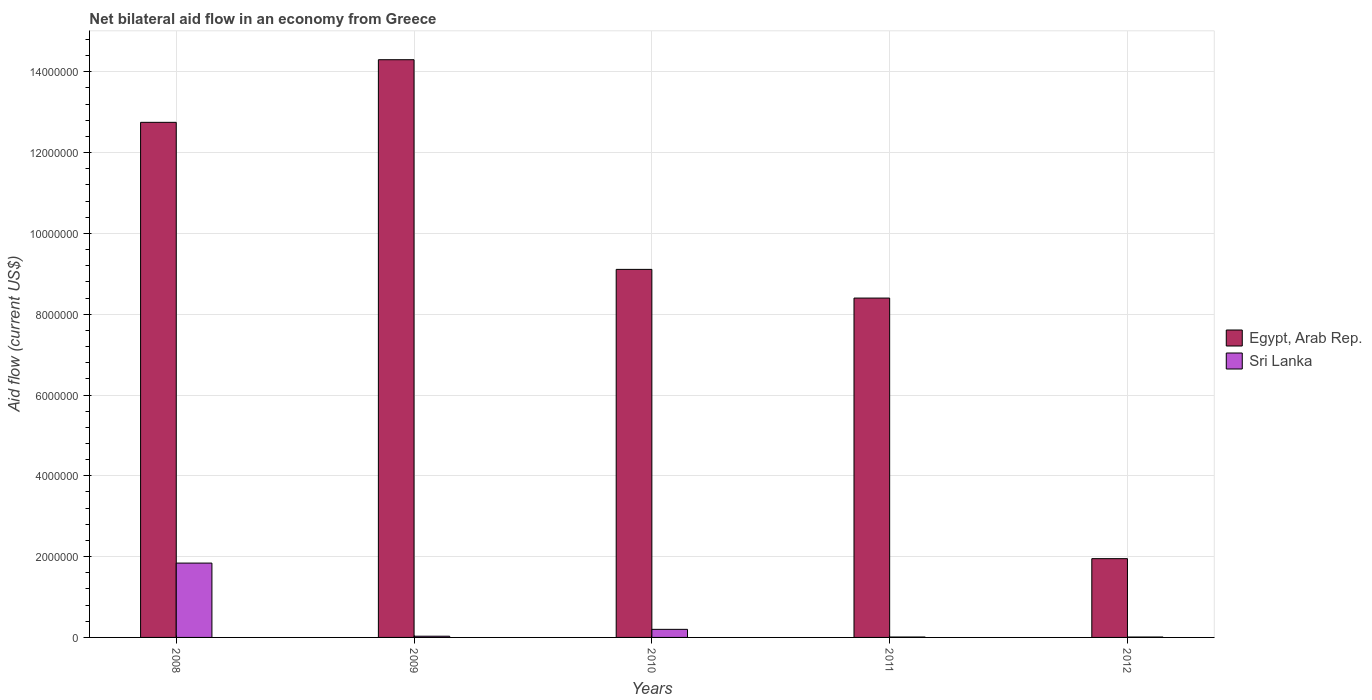How many different coloured bars are there?
Offer a terse response. 2. How many groups of bars are there?
Keep it short and to the point. 5. Are the number of bars on each tick of the X-axis equal?
Your answer should be very brief. Yes. How many bars are there on the 1st tick from the left?
Keep it short and to the point. 2. In how many cases, is the number of bars for a given year not equal to the number of legend labels?
Your response must be concise. 0. What is the net bilateral aid flow in Egypt, Arab Rep. in 2011?
Provide a succinct answer. 8.40e+06. Across all years, what is the maximum net bilateral aid flow in Egypt, Arab Rep.?
Provide a short and direct response. 1.43e+07. Across all years, what is the minimum net bilateral aid flow in Egypt, Arab Rep.?
Give a very brief answer. 1.95e+06. What is the total net bilateral aid flow in Egypt, Arab Rep. in the graph?
Provide a succinct answer. 4.65e+07. What is the difference between the net bilateral aid flow in Sri Lanka in 2008 and that in 2009?
Keep it short and to the point. 1.81e+06. What is the difference between the net bilateral aid flow in Egypt, Arab Rep. in 2011 and the net bilateral aid flow in Sri Lanka in 2008?
Your answer should be compact. 6.56e+06. What is the average net bilateral aid flow in Sri Lanka per year?
Make the answer very short. 4.18e+05. In the year 2008, what is the difference between the net bilateral aid flow in Sri Lanka and net bilateral aid flow in Egypt, Arab Rep.?
Provide a short and direct response. -1.09e+07. In how many years, is the net bilateral aid flow in Sri Lanka greater than 14000000 US$?
Your answer should be compact. 0. What is the difference between the highest and the second highest net bilateral aid flow in Egypt, Arab Rep.?
Ensure brevity in your answer.  1.55e+06. What is the difference between the highest and the lowest net bilateral aid flow in Sri Lanka?
Offer a very short reply. 1.83e+06. Is the sum of the net bilateral aid flow in Egypt, Arab Rep. in 2009 and 2012 greater than the maximum net bilateral aid flow in Sri Lanka across all years?
Offer a very short reply. Yes. What does the 2nd bar from the left in 2010 represents?
Give a very brief answer. Sri Lanka. What does the 1st bar from the right in 2009 represents?
Your answer should be compact. Sri Lanka. Are all the bars in the graph horizontal?
Ensure brevity in your answer.  No. Does the graph contain any zero values?
Offer a terse response. No. Where does the legend appear in the graph?
Your answer should be compact. Center right. How are the legend labels stacked?
Provide a short and direct response. Vertical. What is the title of the graph?
Your answer should be very brief. Net bilateral aid flow in an economy from Greece. Does "Micronesia" appear as one of the legend labels in the graph?
Keep it short and to the point. No. What is the label or title of the X-axis?
Provide a succinct answer. Years. What is the Aid flow (current US$) in Egypt, Arab Rep. in 2008?
Keep it short and to the point. 1.28e+07. What is the Aid flow (current US$) of Sri Lanka in 2008?
Offer a terse response. 1.84e+06. What is the Aid flow (current US$) in Egypt, Arab Rep. in 2009?
Ensure brevity in your answer.  1.43e+07. What is the Aid flow (current US$) in Egypt, Arab Rep. in 2010?
Your answer should be compact. 9.11e+06. What is the Aid flow (current US$) of Egypt, Arab Rep. in 2011?
Give a very brief answer. 8.40e+06. What is the Aid flow (current US$) in Egypt, Arab Rep. in 2012?
Ensure brevity in your answer.  1.95e+06. Across all years, what is the maximum Aid flow (current US$) in Egypt, Arab Rep.?
Provide a short and direct response. 1.43e+07. Across all years, what is the maximum Aid flow (current US$) in Sri Lanka?
Offer a terse response. 1.84e+06. Across all years, what is the minimum Aid flow (current US$) of Egypt, Arab Rep.?
Make the answer very short. 1.95e+06. Across all years, what is the minimum Aid flow (current US$) in Sri Lanka?
Your answer should be very brief. 10000. What is the total Aid flow (current US$) in Egypt, Arab Rep. in the graph?
Your answer should be compact. 4.65e+07. What is the total Aid flow (current US$) in Sri Lanka in the graph?
Provide a short and direct response. 2.09e+06. What is the difference between the Aid flow (current US$) in Egypt, Arab Rep. in 2008 and that in 2009?
Offer a very short reply. -1.55e+06. What is the difference between the Aid flow (current US$) of Sri Lanka in 2008 and that in 2009?
Your response must be concise. 1.81e+06. What is the difference between the Aid flow (current US$) in Egypt, Arab Rep. in 2008 and that in 2010?
Your answer should be compact. 3.64e+06. What is the difference between the Aid flow (current US$) in Sri Lanka in 2008 and that in 2010?
Give a very brief answer. 1.64e+06. What is the difference between the Aid flow (current US$) of Egypt, Arab Rep. in 2008 and that in 2011?
Offer a very short reply. 4.35e+06. What is the difference between the Aid flow (current US$) in Sri Lanka in 2008 and that in 2011?
Your answer should be compact. 1.83e+06. What is the difference between the Aid flow (current US$) in Egypt, Arab Rep. in 2008 and that in 2012?
Give a very brief answer. 1.08e+07. What is the difference between the Aid flow (current US$) in Sri Lanka in 2008 and that in 2012?
Provide a succinct answer. 1.83e+06. What is the difference between the Aid flow (current US$) of Egypt, Arab Rep. in 2009 and that in 2010?
Provide a short and direct response. 5.19e+06. What is the difference between the Aid flow (current US$) of Sri Lanka in 2009 and that in 2010?
Make the answer very short. -1.70e+05. What is the difference between the Aid flow (current US$) of Egypt, Arab Rep. in 2009 and that in 2011?
Provide a succinct answer. 5.90e+06. What is the difference between the Aid flow (current US$) of Egypt, Arab Rep. in 2009 and that in 2012?
Offer a terse response. 1.24e+07. What is the difference between the Aid flow (current US$) in Egypt, Arab Rep. in 2010 and that in 2011?
Give a very brief answer. 7.10e+05. What is the difference between the Aid flow (current US$) in Sri Lanka in 2010 and that in 2011?
Your response must be concise. 1.90e+05. What is the difference between the Aid flow (current US$) of Egypt, Arab Rep. in 2010 and that in 2012?
Your response must be concise. 7.16e+06. What is the difference between the Aid flow (current US$) of Egypt, Arab Rep. in 2011 and that in 2012?
Offer a very short reply. 6.45e+06. What is the difference between the Aid flow (current US$) in Sri Lanka in 2011 and that in 2012?
Ensure brevity in your answer.  0. What is the difference between the Aid flow (current US$) of Egypt, Arab Rep. in 2008 and the Aid flow (current US$) of Sri Lanka in 2009?
Your answer should be very brief. 1.27e+07. What is the difference between the Aid flow (current US$) of Egypt, Arab Rep. in 2008 and the Aid flow (current US$) of Sri Lanka in 2010?
Give a very brief answer. 1.26e+07. What is the difference between the Aid flow (current US$) of Egypt, Arab Rep. in 2008 and the Aid flow (current US$) of Sri Lanka in 2011?
Provide a short and direct response. 1.27e+07. What is the difference between the Aid flow (current US$) of Egypt, Arab Rep. in 2008 and the Aid flow (current US$) of Sri Lanka in 2012?
Ensure brevity in your answer.  1.27e+07. What is the difference between the Aid flow (current US$) of Egypt, Arab Rep. in 2009 and the Aid flow (current US$) of Sri Lanka in 2010?
Your answer should be compact. 1.41e+07. What is the difference between the Aid flow (current US$) of Egypt, Arab Rep. in 2009 and the Aid flow (current US$) of Sri Lanka in 2011?
Your answer should be very brief. 1.43e+07. What is the difference between the Aid flow (current US$) in Egypt, Arab Rep. in 2009 and the Aid flow (current US$) in Sri Lanka in 2012?
Provide a short and direct response. 1.43e+07. What is the difference between the Aid flow (current US$) in Egypt, Arab Rep. in 2010 and the Aid flow (current US$) in Sri Lanka in 2011?
Your answer should be compact. 9.10e+06. What is the difference between the Aid flow (current US$) in Egypt, Arab Rep. in 2010 and the Aid flow (current US$) in Sri Lanka in 2012?
Provide a short and direct response. 9.10e+06. What is the difference between the Aid flow (current US$) in Egypt, Arab Rep. in 2011 and the Aid flow (current US$) in Sri Lanka in 2012?
Provide a succinct answer. 8.39e+06. What is the average Aid flow (current US$) in Egypt, Arab Rep. per year?
Make the answer very short. 9.30e+06. What is the average Aid flow (current US$) in Sri Lanka per year?
Provide a short and direct response. 4.18e+05. In the year 2008, what is the difference between the Aid flow (current US$) of Egypt, Arab Rep. and Aid flow (current US$) of Sri Lanka?
Offer a very short reply. 1.09e+07. In the year 2009, what is the difference between the Aid flow (current US$) in Egypt, Arab Rep. and Aid flow (current US$) in Sri Lanka?
Your answer should be very brief. 1.43e+07. In the year 2010, what is the difference between the Aid flow (current US$) of Egypt, Arab Rep. and Aid flow (current US$) of Sri Lanka?
Your answer should be very brief. 8.91e+06. In the year 2011, what is the difference between the Aid flow (current US$) in Egypt, Arab Rep. and Aid flow (current US$) in Sri Lanka?
Offer a terse response. 8.39e+06. In the year 2012, what is the difference between the Aid flow (current US$) of Egypt, Arab Rep. and Aid flow (current US$) of Sri Lanka?
Provide a succinct answer. 1.94e+06. What is the ratio of the Aid flow (current US$) in Egypt, Arab Rep. in 2008 to that in 2009?
Ensure brevity in your answer.  0.89. What is the ratio of the Aid flow (current US$) of Sri Lanka in 2008 to that in 2009?
Your answer should be compact. 61.33. What is the ratio of the Aid flow (current US$) in Egypt, Arab Rep. in 2008 to that in 2010?
Offer a terse response. 1.4. What is the ratio of the Aid flow (current US$) of Sri Lanka in 2008 to that in 2010?
Keep it short and to the point. 9.2. What is the ratio of the Aid flow (current US$) of Egypt, Arab Rep. in 2008 to that in 2011?
Your answer should be very brief. 1.52. What is the ratio of the Aid flow (current US$) of Sri Lanka in 2008 to that in 2011?
Your answer should be very brief. 184. What is the ratio of the Aid flow (current US$) in Egypt, Arab Rep. in 2008 to that in 2012?
Offer a terse response. 6.54. What is the ratio of the Aid flow (current US$) in Sri Lanka in 2008 to that in 2012?
Provide a short and direct response. 184. What is the ratio of the Aid flow (current US$) of Egypt, Arab Rep. in 2009 to that in 2010?
Keep it short and to the point. 1.57. What is the ratio of the Aid flow (current US$) in Egypt, Arab Rep. in 2009 to that in 2011?
Your answer should be compact. 1.7. What is the ratio of the Aid flow (current US$) in Sri Lanka in 2009 to that in 2011?
Make the answer very short. 3. What is the ratio of the Aid flow (current US$) in Egypt, Arab Rep. in 2009 to that in 2012?
Your answer should be compact. 7.33. What is the ratio of the Aid flow (current US$) of Sri Lanka in 2009 to that in 2012?
Keep it short and to the point. 3. What is the ratio of the Aid flow (current US$) in Egypt, Arab Rep. in 2010 to that in 2011?
Provide a succinct answer. 1.08. What is the ratio of the Aid flow (current US$) of Sri Lanka in 2010 to that in 2011?
Offer a very short reply. 20. What is the ratio of the Aid flow (current US$) in Egypt, Arab Rep. in 2010 to that in 2012?
Keep it short and to the point. 4.67. What is the ratio of the Aid flow (current US$) of Sri Lanka in 2010 to that in 2012?
Keep it short and to the point. 20. What is the ratio of the Aid flow (current US$) in Egypt, Arab Rep. in 2011 to that in 2012?
Your answer should be compact. 4.31. What is the ratio of the Aid flow (current US$) of Sri Lanka in 2011 to that in 2012?
Ensure brevity in your answer.  1. What is the difference between the highest and the second highest Aid flow (current US$) of Egypt, Arab Rep.?
Your response must be concise. 1.55e+06. What is the difference between the highest and the second highest Aid flow (current US$) of Sri Lanka?
Provide a succinct answer. 1.64e+06. What is the difference between the highest and the lowest Aid flow (current US$) of Egypt, Arab Rep.?
Make the answer very short. 1.24e+07. What is the difference between the highest and the lowest Aid flow (current US$) in Sri Lanka?
Your answer should be compact. 1.83e+06. 